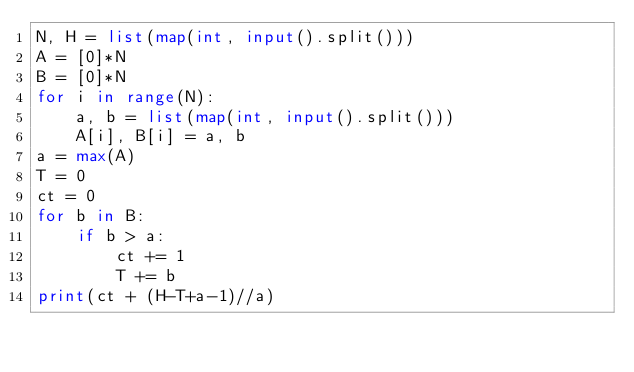Convert code to text. <code><loc_0><loc_0><loc_500><loc_500><_Python_>N, H = list(map(int, input().split()))
A = [0]*N
B = [0]*N
for i in range(N):
    a, b = list(map(int, input().split()))
    A[i], B[i] = a, b
a = max(A)
T = 0
ct = 0
for b in B:
    if b > a:
        ct += 1
        T += b
print(ct + (H-T+a-1)//a)
</code> 